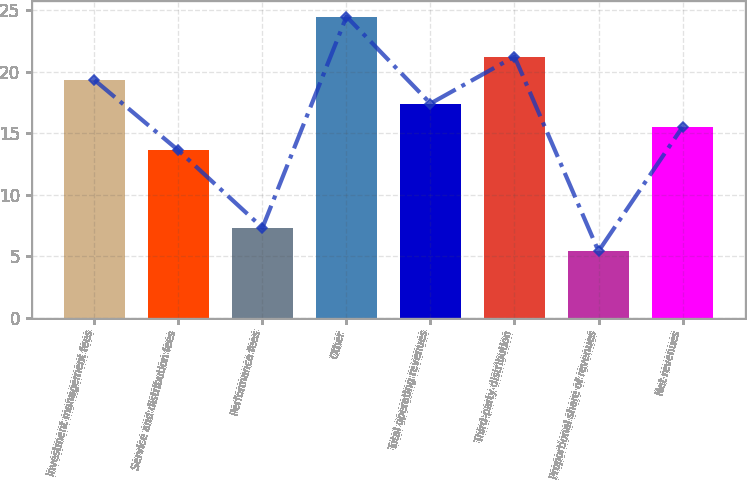<chart> <loc_0><loc_0><loc_500><loc_500><bar_chart><fcel>Investment management fees<fcel>Service and distribution fees<fcel>Performance fees<fcel>Other<fcel>Total operating revenues<fcel>Third-party distribution<fcel>Proportional share of revenues<fcel>Net revenues<nl><fcel>19.33<fcel>13.6<fcel>7.31<fcel>24.5<fcel>17.42<fcel>21.24<fcel>5.4<fcel>15.51<nl></chart> 